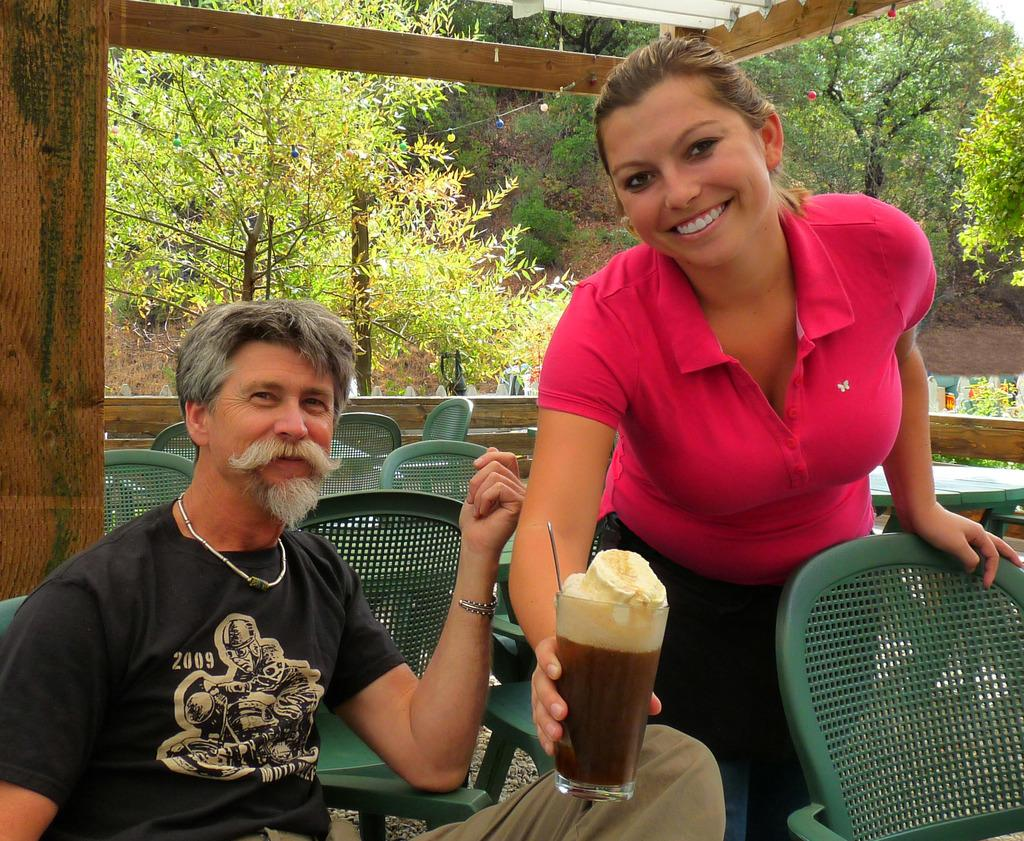What is the man in the image doing? A: The man is sitting on a chair in the image. What is the woman in the image doing? The woman is standing in the image and holding a juice glass in her hand. What can be seen in the background of the image? There are tables, chairs, and trees visible in the background of the image. What type of bird can be seen flying in the image? There is no bird visible in the image. What time of day is it in the image, given the presence of morning light? The provided facts do not mention any specific time of day or lighting conditions, so it cannot be determined if it is morning or not. 